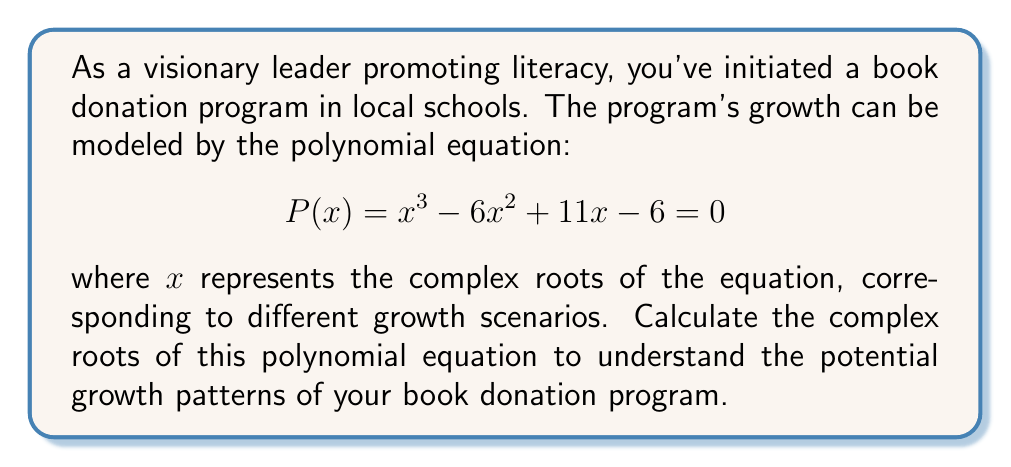Show me your answer to this math problem. To find the complex roots of the given polynomial equation, we'll follow these steps:

1) First, let's check if there are any rational roots using the rational root theorem. The possible rational roots are the factors of the constant term: ±1, ±2, ±3, ±6.

2) By testing these values, we find that $x = 1$ is a root of the equation.

3) Now we can factor out $(x - 1)$ from the original polynomial:

   $$x^3 - 6x^2 + 11x - 6 = (x - 1)(x^2 - 5x + 6)$$

4) We now need to solve the quadratic equation $x^2 - 5x + 6 = 0$

5) We can use the quadratic formula: $x = \frac{-b \pm \sqrt{b^2 - 4ac}}{2a}$

   Where $a = 1$, $b = -5$, and $c = 6$

6) Substituting these values:

   $$x = \frac{5 \pm \sqrt{25 - 24}}{2} = \frac{5 \pm 1}{2}$$

7) This gives us two more roots:

   $$x = \frac{5 + 1}{2} = 3$$ and $$x = \frac{5 - 1}{2} = 2$$

Therefore, the three roots of the equation are real numbers: 1, 2, and 3.
Answer: The complex roots of the polynomial equation $P(x) = x^3 - 6x^2 + 11x - 6 = 0$ are:
$x_1 = 1$, $x_2 = 2$, and $x_3 = 3$ 